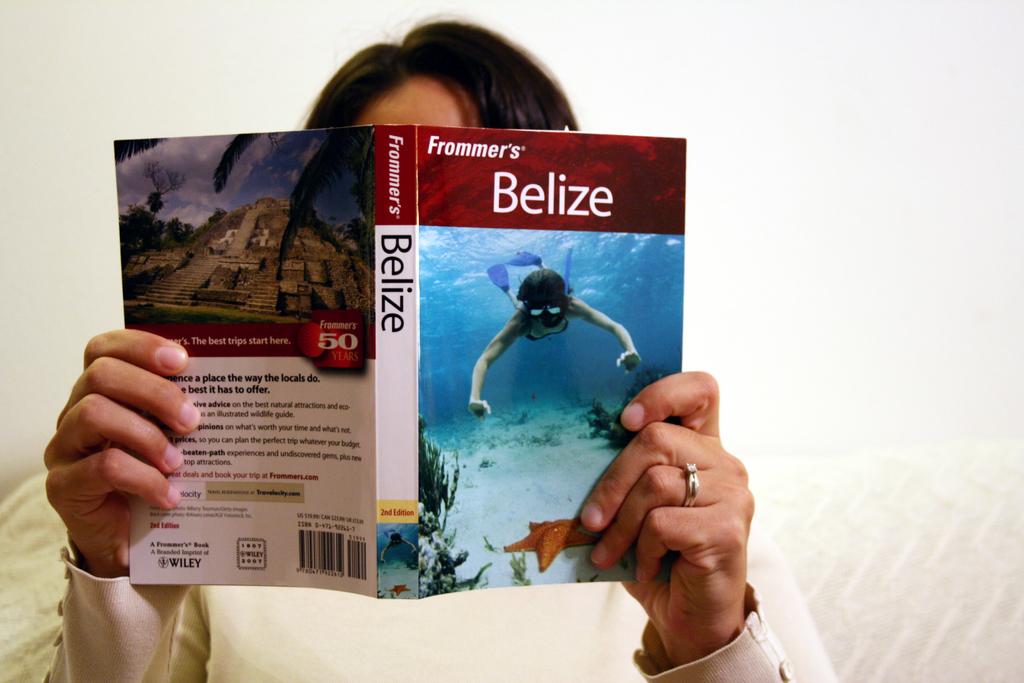What is the title?
Ensure brevity in your answer.  Belize. 